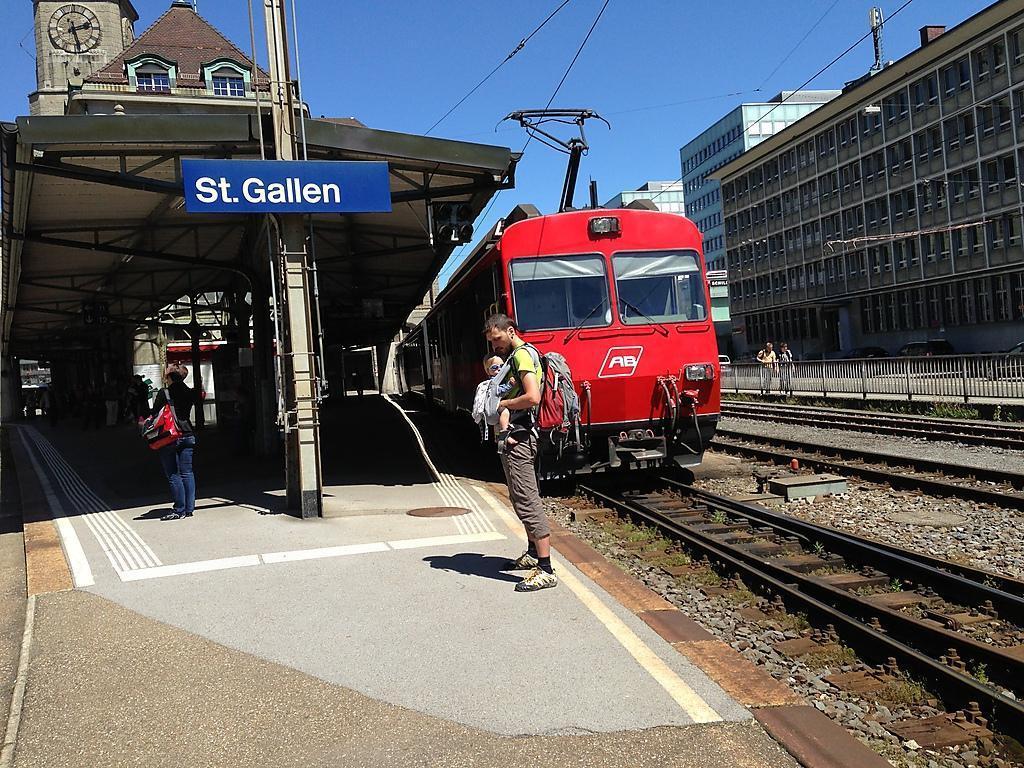How many people are holding babies?
Give a very brief answer. 1. 